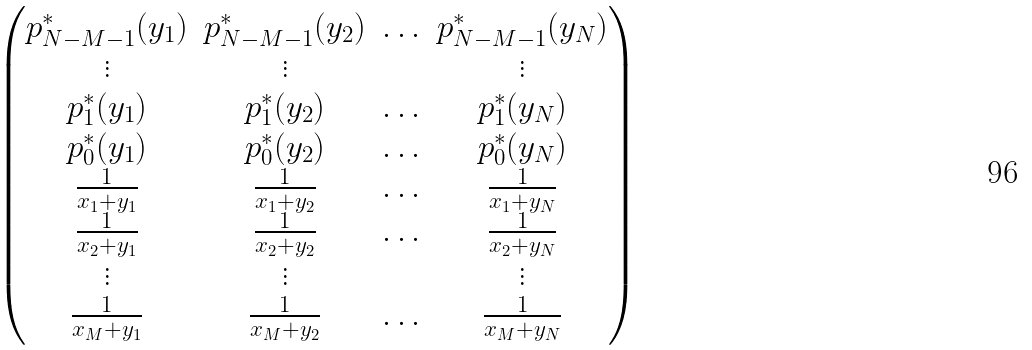<formula> <loc_0><loc_0><loc_500><loc_500>\begin{pmatrix} p ^ { * } _ { N - M - 1 } ( y _ { 1 } ) & p ^ { * } _ { N - M - 1 } ( y _ { 2 } ) & \hdots & p ^ { * } _ { N - M - 1 } ( y _ { N } ) \\ \vdots & \vdots & & \vdots \\ p ^ { * } _ { 1 } ( y _ { 1 } ) & p ^ { * } _ { 1 } ( y _ { 2 } ) & \hdots & p ^ { * } _ { 1 } ( y _ { N } ) \\ p ^ { * } _ { 0 } ( y _ { 1 } ) & p ^ { * } _ { 0 } ( y _ { 2 } ) & \hdots & p ^ { * } _ { 0 } ( y _ { N } ) \\ \frac { 1 } { x _ { 1 } + y _ { 1 } } & \frac { 1 } { x _ { 1 } + y _ { 2 } } & \hdots & \frac { 1 } { x _ { 1 } + y _ { N } } \\ \frac { 1 } { x _ { 2 } + y _ { 1 } } & \frac { 1 } { x _ { 2 } + y _ { 2 } } & \hdots & \frac { 1 } { x _ { 2 } + y _ { N } } \\ \vdots & \vdots & & \vdots \\ \frac { 1 } { x _ { M } + y _ { 1 } } & \frac { 1 } { x _ { M } + y _ { 2 } } & \hdots & \frac { 1 } { x _ { M } + y _ { N } } \\ \end{pmatrix}</formula> 